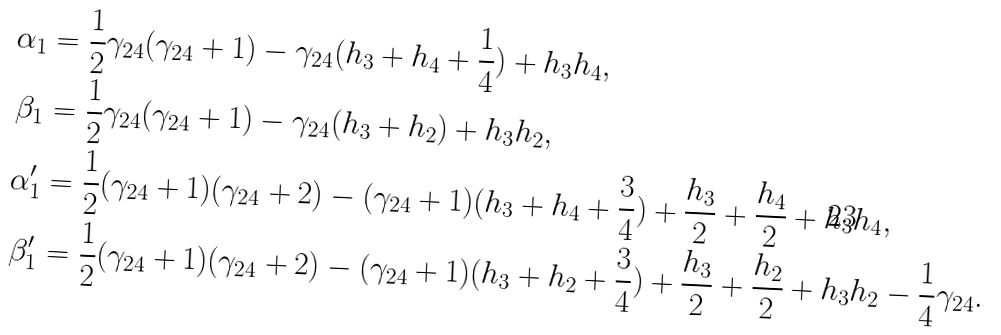<formula> <loc_0><loc_0><loc_500><loc_500>\alpha _ { 1 } & = \frac { 1 } { 2 } \gamma _ { 2 4 } ( \gamma _ { 2 4 } + 1 ) - \gamma _ { 2 4 } ( h _ { 3 } + h _ { 4 } + \frac { 1 } { 4 } ) + h _ { 3 } h _ { 4 } , \\ \beta _ { 1 } & = \frac { 1 } { 2 } \gamma _ { 2 4 } ( \gamma _ { 2 4 } + 1 ) - \gamma _ { 2 4 } ( h _ { 3 } + h _ { 2 } ) + h _ { 3 } h _ { 2 } , \\ \alpha ^ { \prime } _ { 1 } & = \frac { 1 } { 2 } ( \gamma _ { 2 4 } + 1 ) ( \gamma _ { 2 4 } + 2 ) - ( \gamma _ { 2 4 } + 1 ) ( h _ { 3 } + h _ { 4 } + \frac { 3 } { 4 } ) + \frac { h _ { 3 } } { 2 } + \frac { h _ { 4 } } { 2 } + h _ { 3 } h _ { 4 } , \\ \beta ^ { \prime } _ { 1 } & = \frac { 1 } { 2 } ( \gamma _ { 2 4 } + 1 ) ( \gamma _ { 2 4 } + 2 ) - ( \gamma _ { 2 4 } + 1 ) ( h _ { 3 } + h _ { 2 } + \frac { 3 } { 4 } ) + \frac { h _ { 3 } } { 2 } + \frac { h _ { 2 } } { 2 } + h _ { 3 } h _ { 2 } - \frac { 1 } { 4 } \gamma _ { 2 4 } .</formula> 